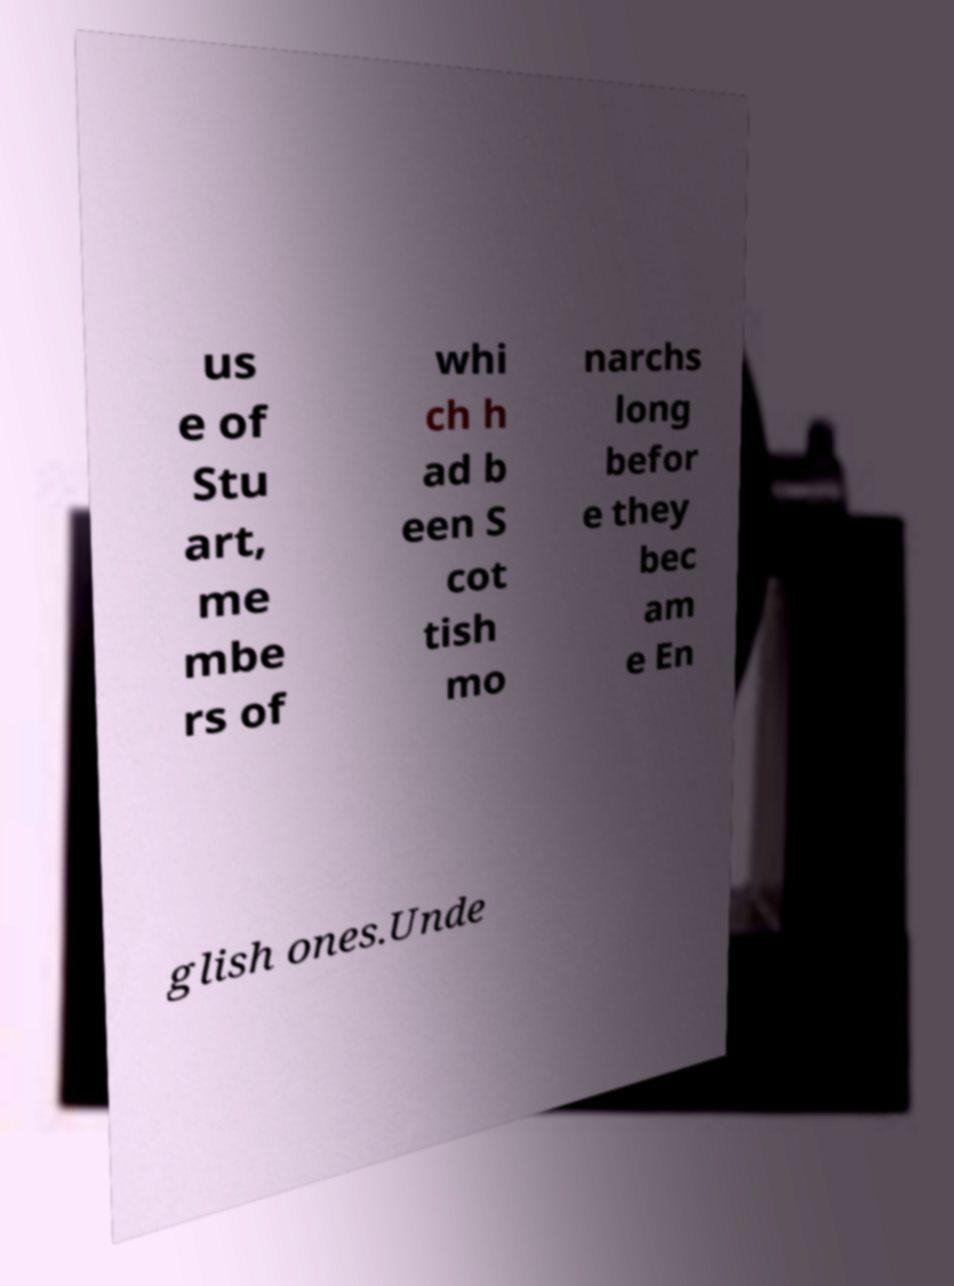Please identify and transcribe the text found in this image. us e of Stu art, me mbe rs of whi ch h ad b een S cot tish mo narchs long befor e they bec am e En glish ones.Unde 